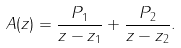Convert formula to latex. <formula><loc_0><loc_0><loc_500><loc_500>A ( z ) = \frac { P _ { 1 } } { z - z _ { 1 } } + \frac { P _ { 2 } } { z - z _ { 2 } } .</formula> 